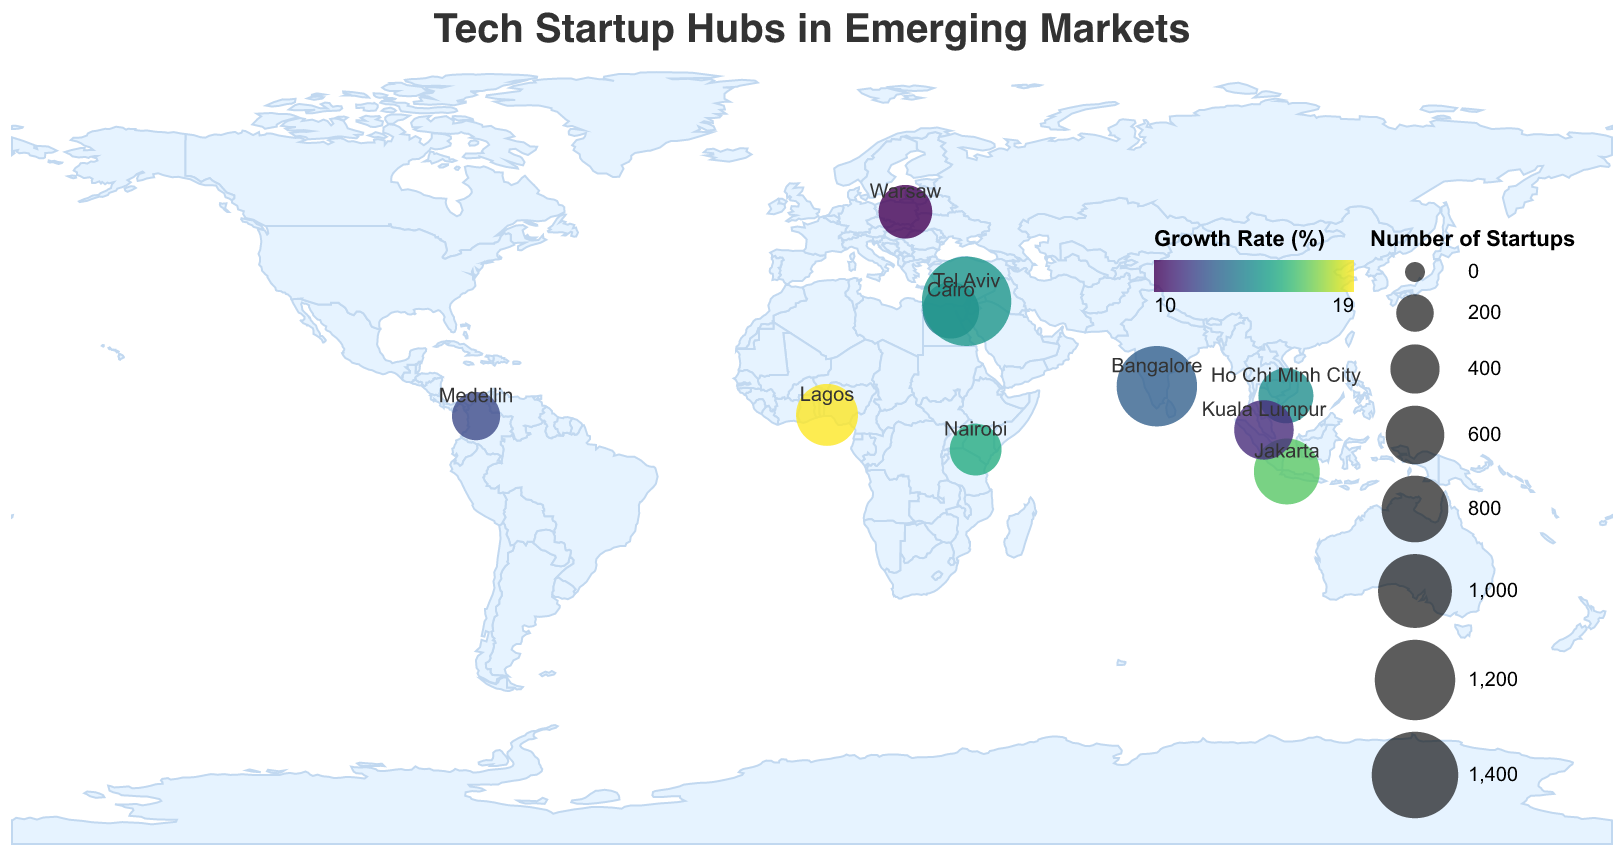How many cities are shown on the map? The figure contains markers for each of the cities included in the data. You can count the data points to find the total number of cities represented.
Answer: 10 Which city has the highest number of tech startups? To find the city with the highest number of tech startups, compare the "Startup_Count" values for each city. Tel Aviv has the highest number with 1500 tech startups.
Answer: Tel Aviv What is the title of the plot? The title is displayed at the top of the plot. It reads, "Tech Startup Hubs in Emerging Markets".
Answer: Tech Startup Hubs in Emerging Markets Which city has a higher growth rate, Bangalore or Lagos? Compare the "Growth_Rate" values of Bangalore and Lagos. Bangalore has a growth rate of 12.5%, while Lagos has a growth rate of 18.7%. Therefore, Lagos has a higher growth rate.
Answer: Lagos What's the total count of incubators in Cairo and Jakarta? To find the total count of incubators in Cairo and Jakarta, add the "Incubator_Count" values of the two cities: Cairo (20) + Jakarta (30) = 50.
Answer: 50 Which cities have a growth rate greater than 15%? By examining the "Growth_Rate" field for all cities, the cities with a growth rate greater than 15% are Nairobi (15.3%), Lagos (18.7%), and Jakarta (16.4%).
Answer: Nairobi, Lagos, Jakarta What color represents the highest growth rate on the map? The color legend indicates the "Growth Rate (%)". The most intense color in the viridis color scheme represents the highest growth rate.
Answer: The darkest color in the viridis color scheme Compare the number of tech startups in Tel Aviv and Bangalore. Which city has more? Compare the "Startup_Count" field for Tel Aviv and Bangalore. Tel Aviv has 1500 startups, while Bangalore has 1200. Therefore, Tel Aviv has more startups.
Answer: Tel Aviv What is the average number of tech startups across all cities? Sum the "Startup_Count" across all cities and divide by the number of cities. The total is 1200+450+680+520+380+550+780+620+490+1500 = 7170. Dividing by 10 cities, the average is 717.
Answer: 717 Which city in Africa has the most tech startups? Look for the cities located in Africa and compare their "Startup_Count". Nairobi has 450 and Lagos has 680. Therefore, Lagos has the most tech startups.
Answer: Lagos 